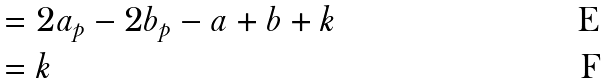<formula> <loc_0><loc_0><loc_500><loc_500>& = 2 a _ { p } - 2 b _ { p } - a + b + k \\ & = k</formula> 